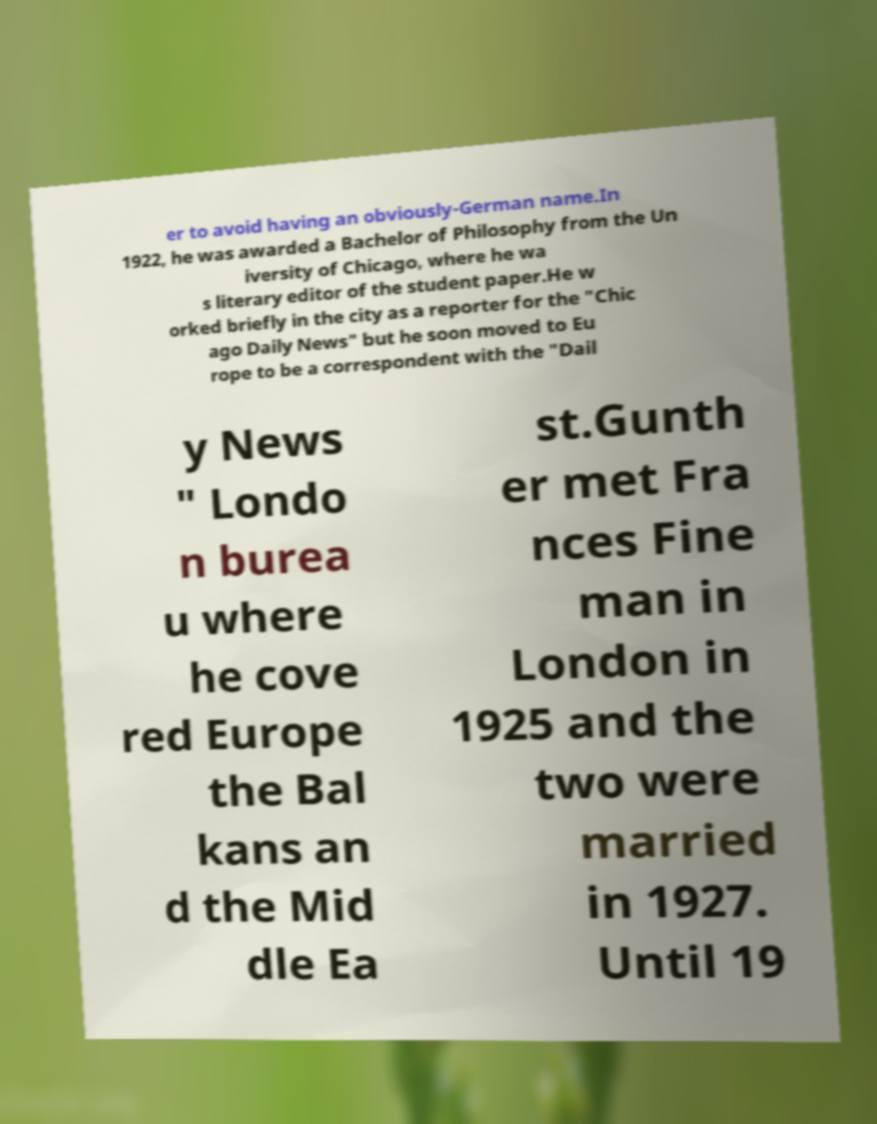Can you accurately transcribe the text from the provided image for me? er to avoid having an obviously-German name.In 1922, he was awarded a Bachelor of Philosophy from the Un iversity of Chicago, where he wa s literary editor of the student paper.He w orked briefly in the city as a reporter for the "Chic ago Daily News" but he soon moved to Eu rope to be a correspondent with the "Dail y News " Londo n burea u where he cove red Europe the Bal kans an d the Mid dle Ea st.Gunth er met Fra nces Fine man in London in 1925 and the two were married in 1927. Until 19 